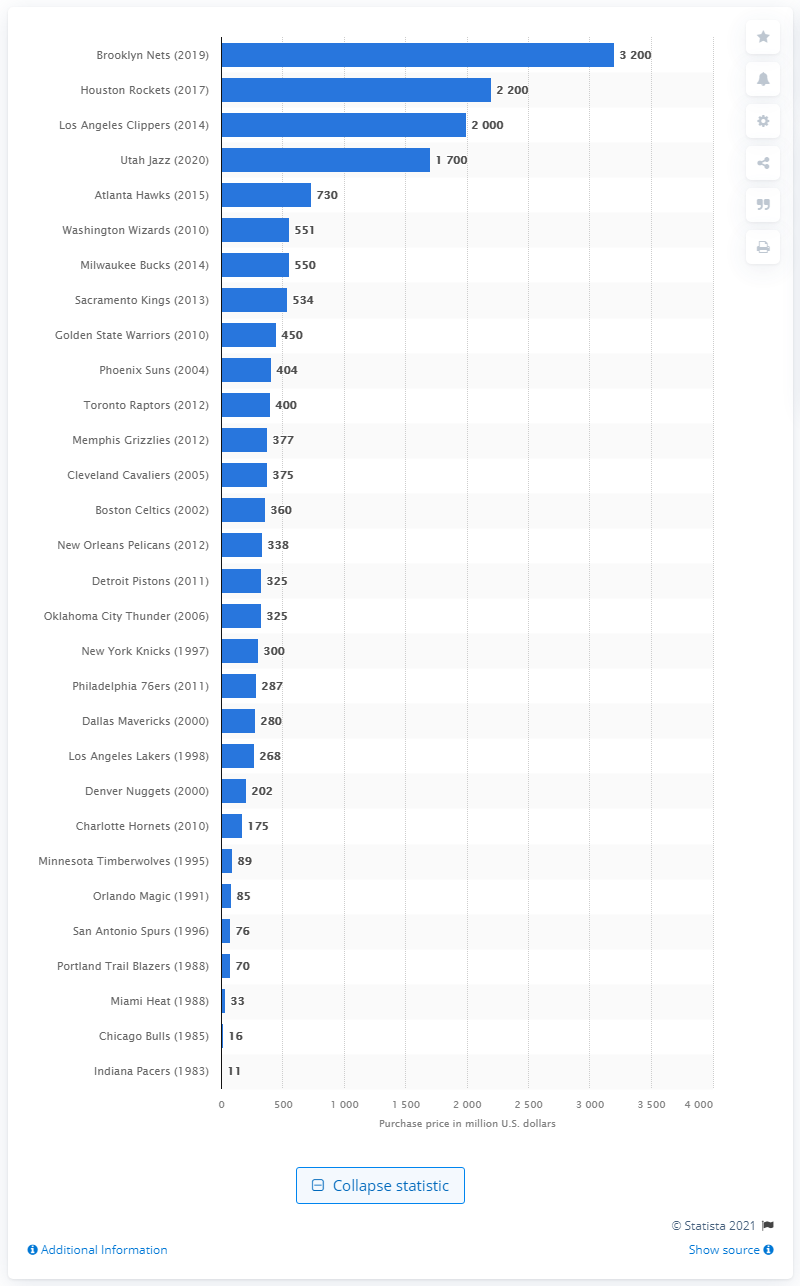Indicate a few pertinent items in this graphic. The amount that Joe Tsai paid for the Brooklyn Nets is 3,200. 